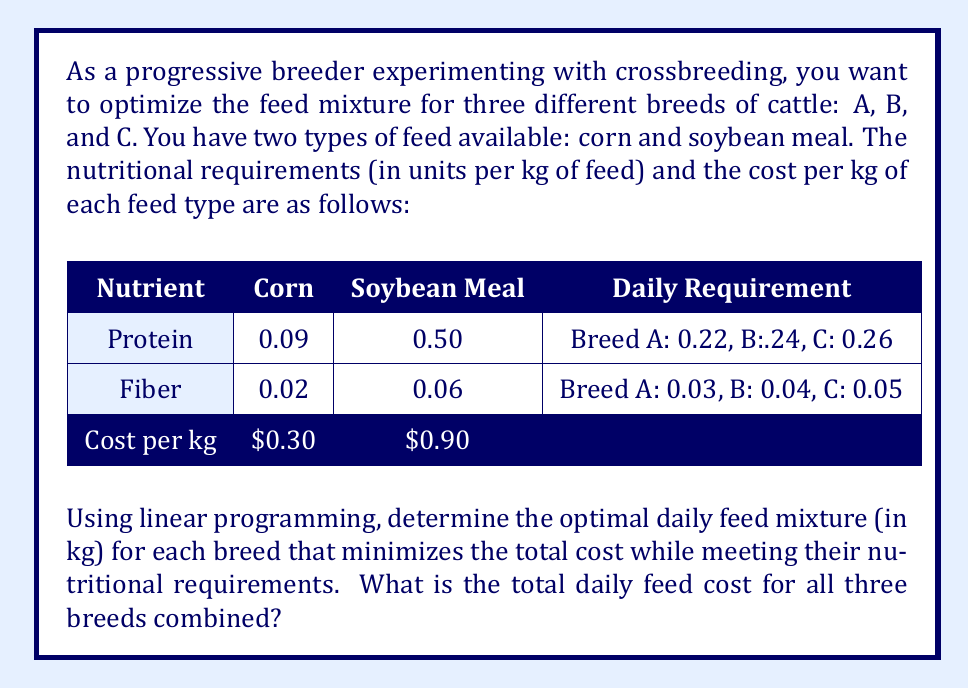Can you solve this math problem? To solve this problem, we'll use linear programming for each breed separately and then combine the results. Let's define variables and set up the linear programming problem for each breed:

Let $x$ be the amount of corn (in kg) and $y$ be the amount of soybean meal (in kg).

For Breed A:
Minimize: $0.30x + 0.90y$
Subject to:
$0.09x + 0.50y \geq 0.22$ (Protein requirement)
$0.02x + 0.06y \geq 0.03$ (Fiber requirement)
$x, y \geq 0$ (Non-negativity constraints)

For Breed B:
Minimize: $0.30x + 0.90y$
Subject to:
$0.09x + 0.50y \geq 0.24$ (Protein requirement)
$0.02x + 0.06y \geq 0.04$ (Fiber requirement)
$x, y \geq 0$ (Non-negativity constraints)

For Breed C:
Minimize: $0.30x + 0.90y$
Subject to:
$0.09x + 0.50y \geq 0.26$ (Protein requirement)
$0.02x + 0.06y \geq 0.05$ (Fiber requirement)
$x, y \geq 0$ (Non-negativity constraints)

Using a linear programming solver or graphical method, we can find the optimal solutions:

Breed A: $x = 0.8889$ kg corn, $y = 0.2222$ kg soybean meal
Cost: $0.30(0.8889) + 0.90(0.2222) = \$0.4667$ per day

Breed B: $x = 0.6667$ kg corn, $y = 0.3333$ kg soybean meal
Cost: $0.30(0.6667) + 0.90(0.3333) = \$0.5000$ per day

Breed C: $x = 0.4444$ kg corn, $y = 0.4444$ kg soybean meal
Cost: $0.30(0.4444) + 0.90(0.4444) = \$0.5333$ per day

The total daily feed cost for all three breeds combined is the sum of their individual costs:

$\$0.4667 + \$0.5000 + \$0.5333 = \$1.5000$
Answer: The total daily feed cost for all three breeds combined is $\$1.50$. 